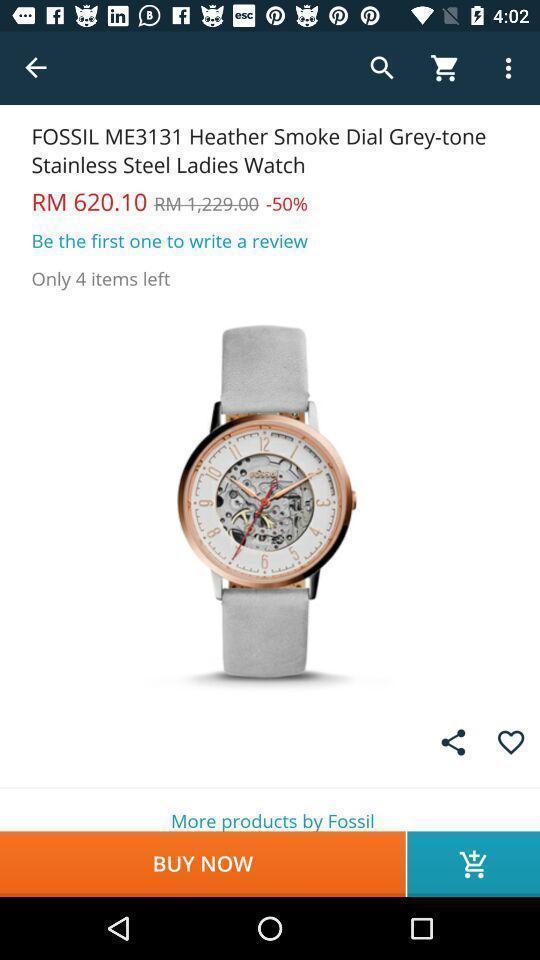Summarize the information in this screenshot. Shopping app displayed an item to buy. 